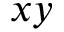<formula> <loc_0><loc_0><loc_500><loc_500>x y</formula> 